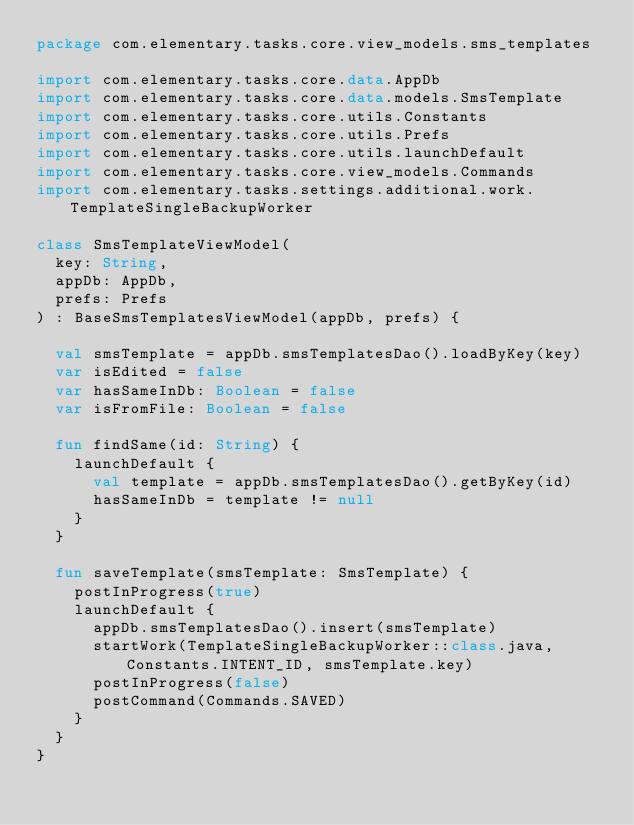<code> <loc_0><loc_0><loc_500><loc_500><_Kotlin_>package com.elementary.tasks.core.view_models.sms_templates

import com.elementary.tasks.core.data.AppDb
import com.elementary.tasks.core.data.models.SmsTemplate
import com.elementary.tasks.core.utils.Constants
import com.elementary.tasks.core.utils.Prefs
import com.elementary.tasks.core.utils.launchDefault
import com.elementary.tasks.core.view_models.Commands
import com.elementary.tasks.settings.additional.work.TemplateSingleBackupWorker

class SmsTemplateViewModel(
  key: String,
  appDb: AppDb,
  prefs: Prefs
) : BaseSmsTemplatesViewModel(appDb, prefs) {

  val smsTemplate = appDb.smsTemplatesDao().loadByKey(key)
  var isEdited = false
  var hasSameInDb: Boolean = false
  var isFromFile: Boolean = false

  fun findSame(id: String) {
    launchDefault {
      val template = appDb.smsTemplatesDao().getByKey(id)
      hasSameInDb = template != null
    }
  }

  fun saveTemplate(smsTemplate: SmsTemplate) {
    postInProgress(true)
    launchDefault {
      appDb.smsTemplatesDao().insert(smsTemplate)
      startWork(TemplateSingleBackupWorker::class.java, Constants.INTENT_ID, smsTemplate.key)
      postInProgress(false)
      postCommand(Commands.SAVED)
    }
  }
}
</code> 